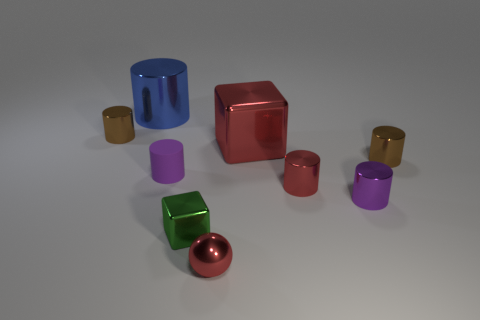There is a small purple metallic thing; is its shape the same as the brown shiny thing that is in front of the large red metallic cube?
Your answer should be very brief. Yes. How many matte objects are either big blue cylinders or tiny green things?
Keep it short and to the point. 0. There is a large thing in front of the shiny cylinder behind the small brown cylinder that is on the left side of the rubber object; what color is it?
Give a very brief answer. Red. How many other objects are there of the same material as the green block?
Make the answer very short. 7. Do the small brown object on the left side of the tiny rubber cylinder and the purple metallic object have the same shape?
Provide a short and direct response. Yes. How many small things are either purple shiny objects or matte cylinders?
Offer a terse response. 2. Are there an equal number of purple cylinders that are behind the big red cube and tiny purple cylinders that are right of the tiny metal cube?
Your answer should be compact. No. How many other things are the same color as the big metal block?
Offer a terse response. 2. There is a small ball; does it have the same color as the block that is in front of the red metal block?
Make the answer very short. No. What number of cyan objects are either small blocks or shiny cylinders?
Your answer should be very brief. 0. 